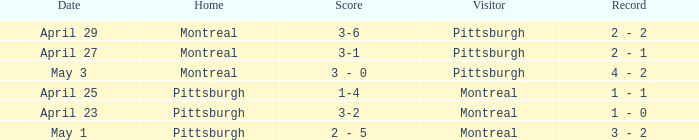When did Montreal visit and have a score of 1-4? April 25. 